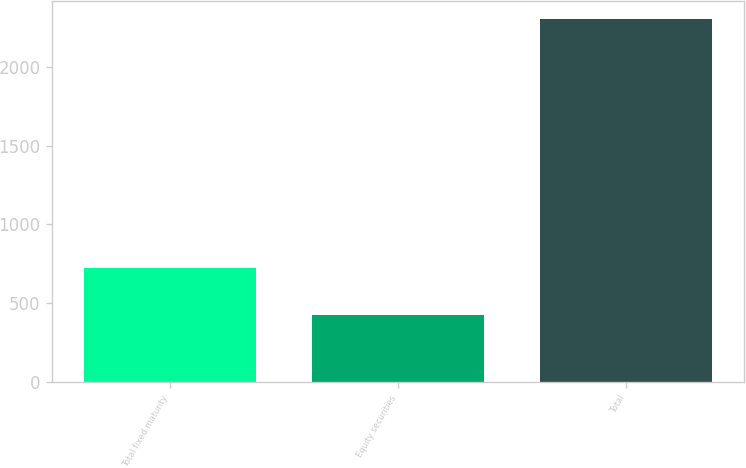Convert chart. <chart><loc_0><loc_0><loc_500><loc_500><bar_chart><fcel>Total fixed maturity<fcel>Equity securities<fcel>Total<nl><fcel>720<fcel>424<fcel>2303<nl></chart> 